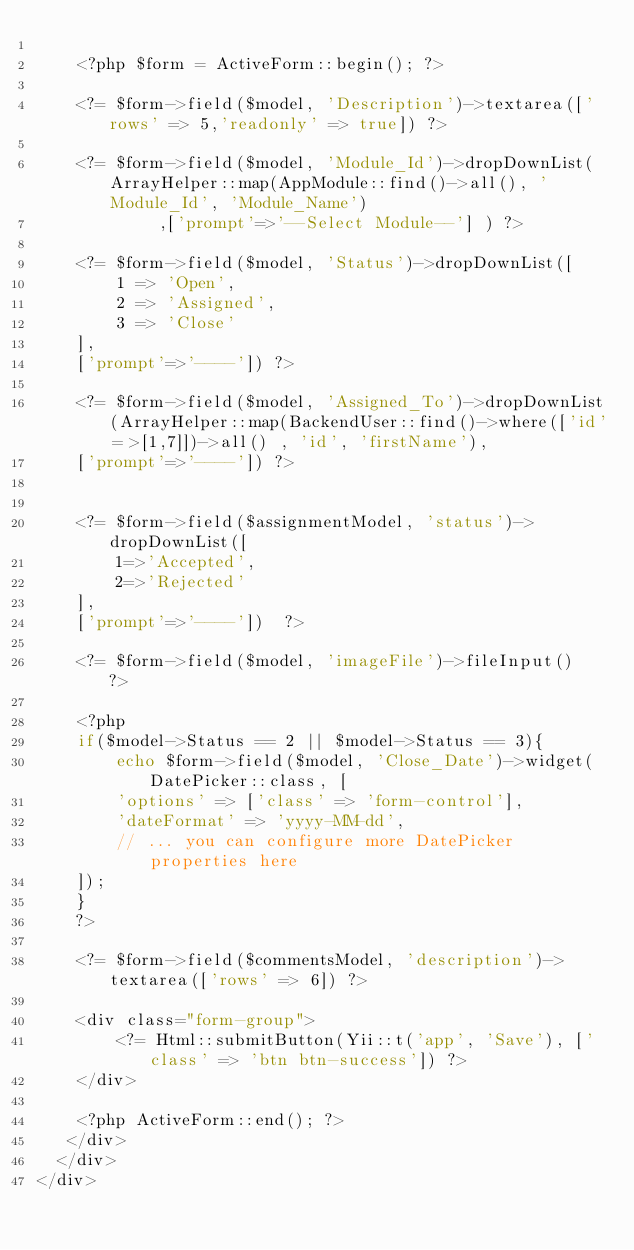<code> <loc_0><loc_0><loc_500><loc_500><_PHP_>       
    <?php $form = ActiveForm::begin(); ?>

    <?= $form->field($model, 'Description')->textarea(['rows' => 5,'readonly' => true]) ?>

    <?= $form->field($model, 'Module_Id')->dropDownList(ArrayHelper::map(AppModule::find()->all(), 'Module_Id', 'Module_Name')
            ,['prompt'=>'--Select Module--'] ) ?>
   
    <?= $form->field($model, 'Status')->dropDownList([
        1 => 'Open',
        2 => 'Assigned',
        3 => 'Close'
    ],
    ['prompt'=>'----']) ?>
    
    <?= $form->field($model, 'Assigned_To')->dropDownList(ArrayHelper::map(BackendUser::find()->where(['id'=>[1,7]])->all() , 'id', 'firstName'),
    ['prompt'=>'----']) ?>

       
    <?= $form->field($assignmentModel, 'status')->dropDownList([
        1=>'Accepted',
        2=>'Rejected'
    ],
    ['prompt'=>'----'])  ?> 
    
    <?= $form->field($model, 'imageFile')->fileInput()  ?> 
       
    <?php
    if($model->Status == 2 || $model->Status == 3){ 
        echo $form->field($model, 'Close_Date')->widget(DatePicker::class, [   
        'options' => ['class' => 'form-control'],
        'dateFormat' => 'yyyy-MM-dd',
        // ... you can configure more DatePicker properties here    
    ]);
    }
    ?>
   
    <?= $form->field($commentsModel, 'description')->textarea(['rows' => 6]) ?>
     
    <div class="form-group">
        <?= Html::submitButton(Yii::t('app', 'Save'), ['class' => 'btn btn-success']) ?>
    </div>

    <?php ActiveForm::end(); ?>
   </div>
  </div>
</div>
</code> 